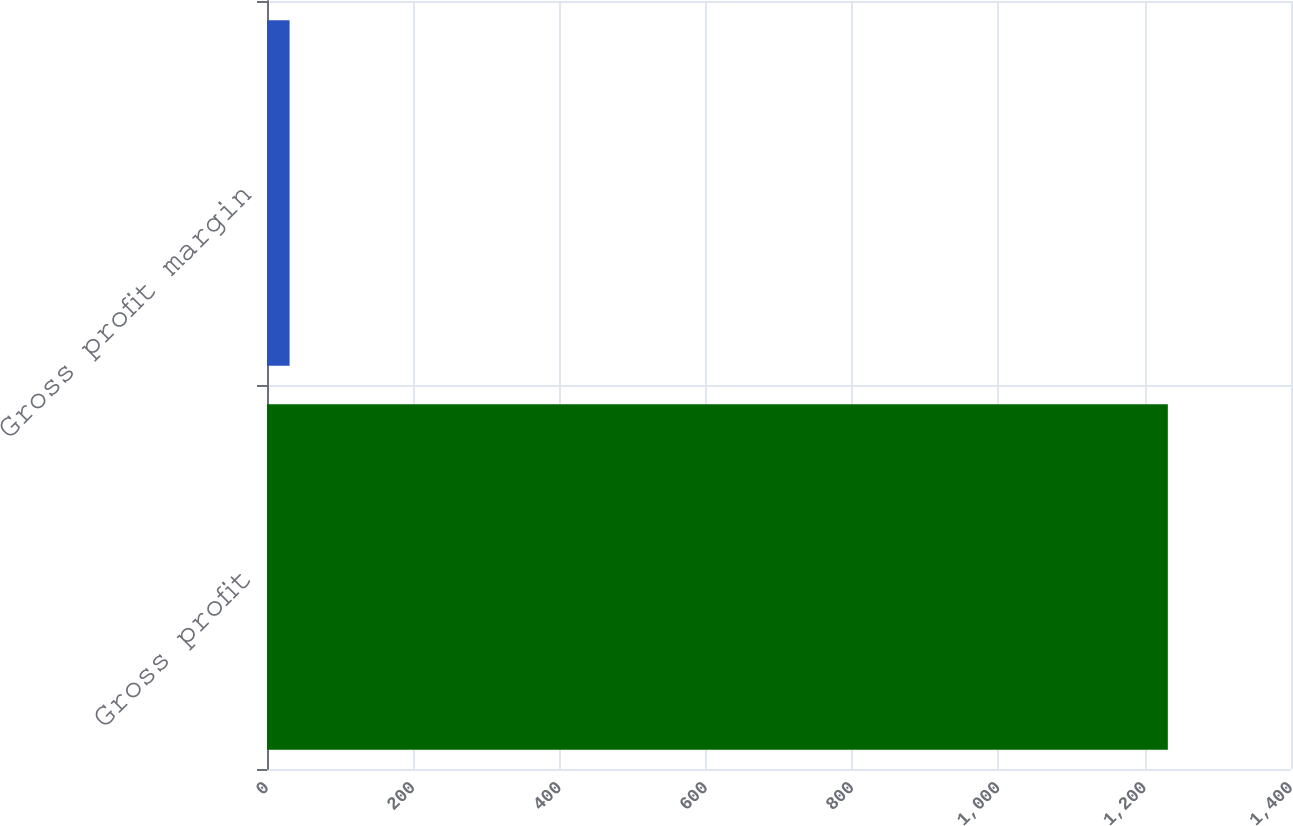Convert chart to OTSL. <chart><loc_0><loc_0><loc_500><loc_500><bar_chart><fcel>Gross profit<fcel>Gross profit margin<nl><fcel>1231.6<fcel>30.9<nl></chart> 